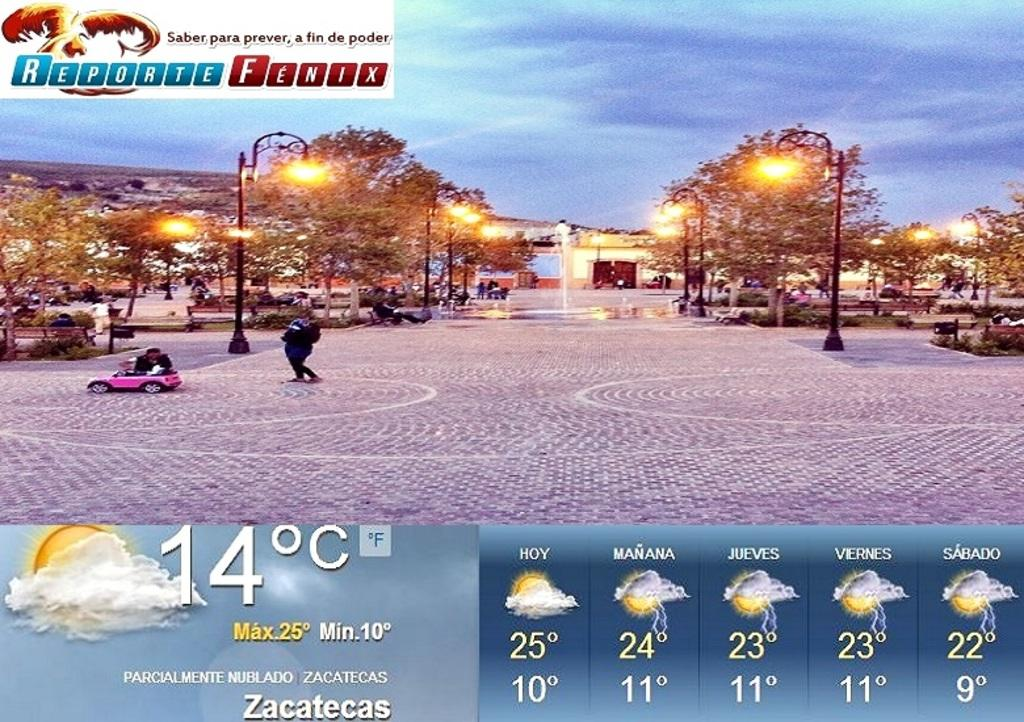<image>
Provide a brief description of the given image. A city park with the weather below it showing a temperature of 14 degrees celsius. 